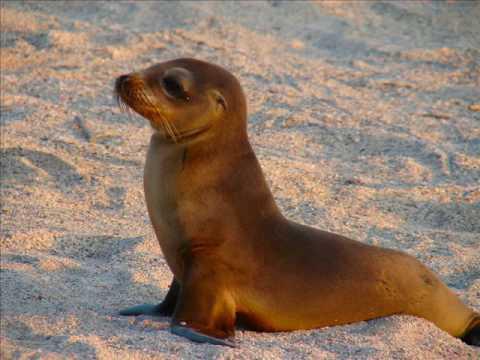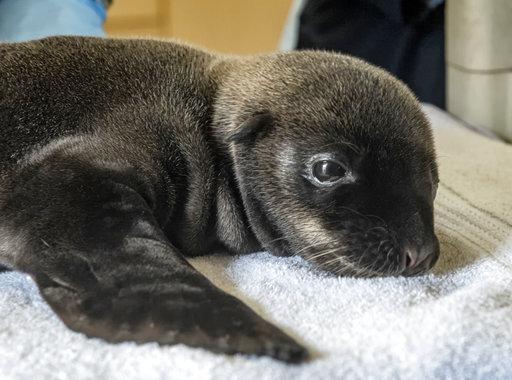The first image is the image on the left, the second image is the image on the right. Examine the images to the left and right. Is the description "the baby seal on the right is lying down." accurate? Answer yes or no. Yes. 